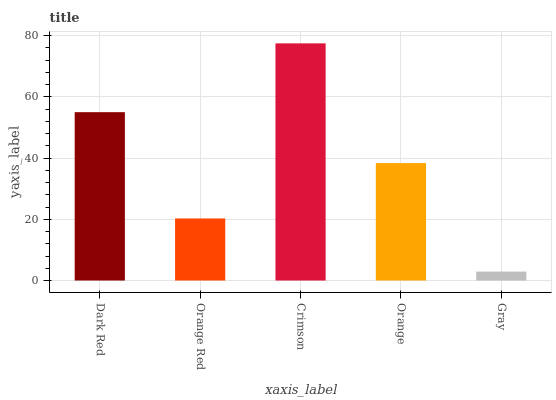Is Gray the minimum?
Answer yes or no. Yes. Is Crimson the maximum?
Answer yes or no. Yes. Is Orange Red the minimum?
Answer yes or no. No. Is Orange Red the maximum?
Answer yes or no. No. Is Dark Red greater than Orange Red?
Answer yes or no. Yes. Is Orange Red less than Dark Red?
Answer yes or no. Yes. Is Orange Red greater than Dark Red?
Answer yes or no. No. Is Dark Red less than Orange Red?
Answer yes or no. No. Is Orange the high median?
Answer yes or no. Yes. Is Orange the low median?
Answer yes or no. Yes. Is Crimson the high median?
Answer yes or no. No. Is Crimson the low median?
Answer yes or no. No. 